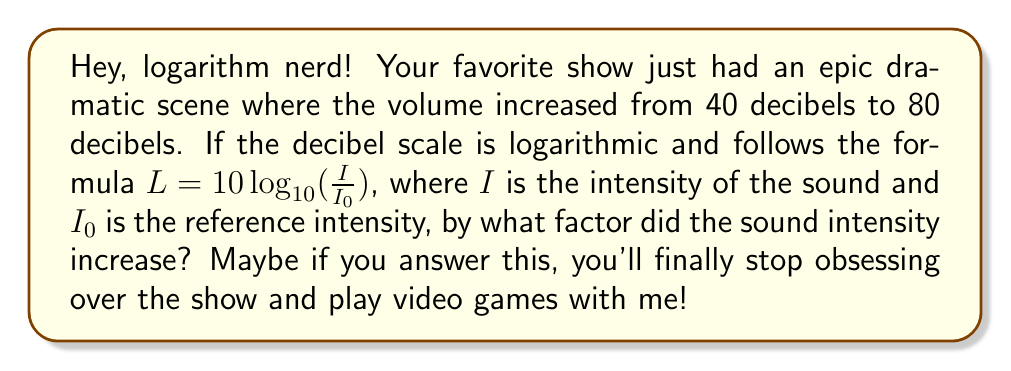Can you solve this math problem? Alright, let's break this down step-by-step:

1) The decibel scale is given by the formula:
   $L = 10 \log_{10}(\frac{I}{I_0})$

2) We have two different decibel levels:
   $L_1 = 40$ dB and $L_2 = 80$ dB

3) Let's call the initial intensity $I_1$ and the final intensity $I_2$. We can write two equations:

   $40 = 10 \log_{10}(\frac{I_1}{I_0})$
   $80 = 10 \log_{10}(\frac{I_2}{I_0})$

4) To find the factor of increase, we need to find $\frac{I_2}{I_1}$. Let's subtract the first equation from the second:

   $80 - 40 = 10 \log_{10}(\frac{I_2}{I_0}) - 10 \log_{10}(\frac{I_1}{I_0})$

5) Simplify:
   $40 = 10 \log_{10}(\frac{I_2/I_0}{I_1/I_0}) = 10 \log_{10}(\frac{I_2}{I_1})$

6) Divide both sides by 10:
   $4 = \log_{10}(\frac{I_2}{I_1})$

7) To solve for $\frac{I_2}{I_1}$, we need to apply $10^x$ to both sides:

   $10^4 = 10^{\log_{10}(\frac{I_2}{I_1})} = \frac{I_2}{I_1}$

8) Calculate:
   $\frac{I_2}{I_1} = 10,000$

Therefore, the sound intensity increased by a factor of 10,000.
Answer: The sound intensity increased by a factor of 10,000. 